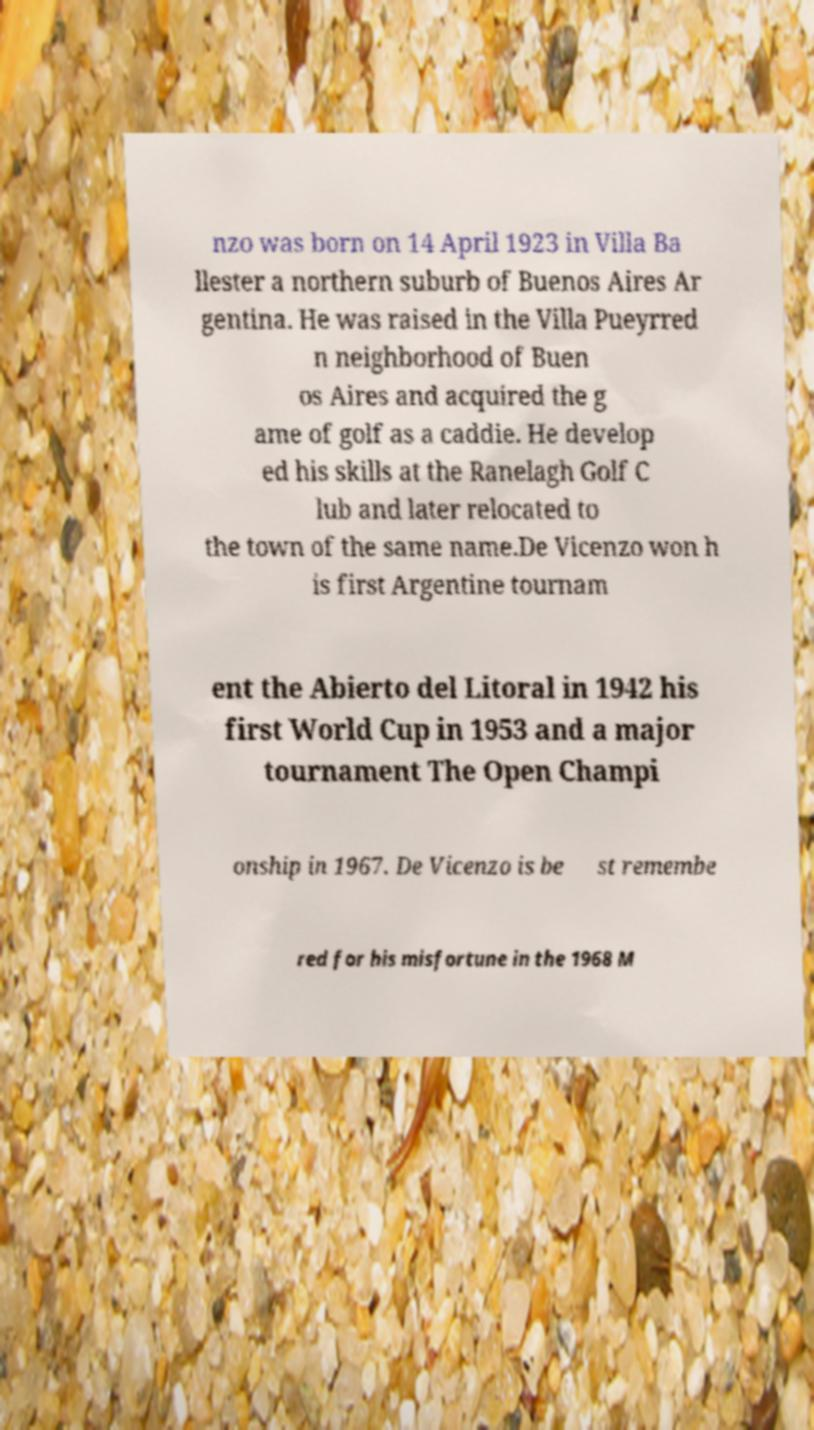Please identify and transcribe the text found in this image. nzo was born on 14 April 1923 in Villa Ba llester a northern suburb of Buenos Aires Ar gentina. He was raised in the Villa Pueyrred n neighborhood of Buen os Aires and acquired the g ame of golf as a caddie. He develop ed his skills at the Ranelagh Golf C lub and later relocated to the town of the same name.De Vicenzo won h is first Argentine tournam ent the Abierto del Litoral in 1942 his first World Cup in 1953 and a major tournament The Open Champi onship in 1967. De Vicenzo is be st remembe red for his misfortune in the 1968 M 